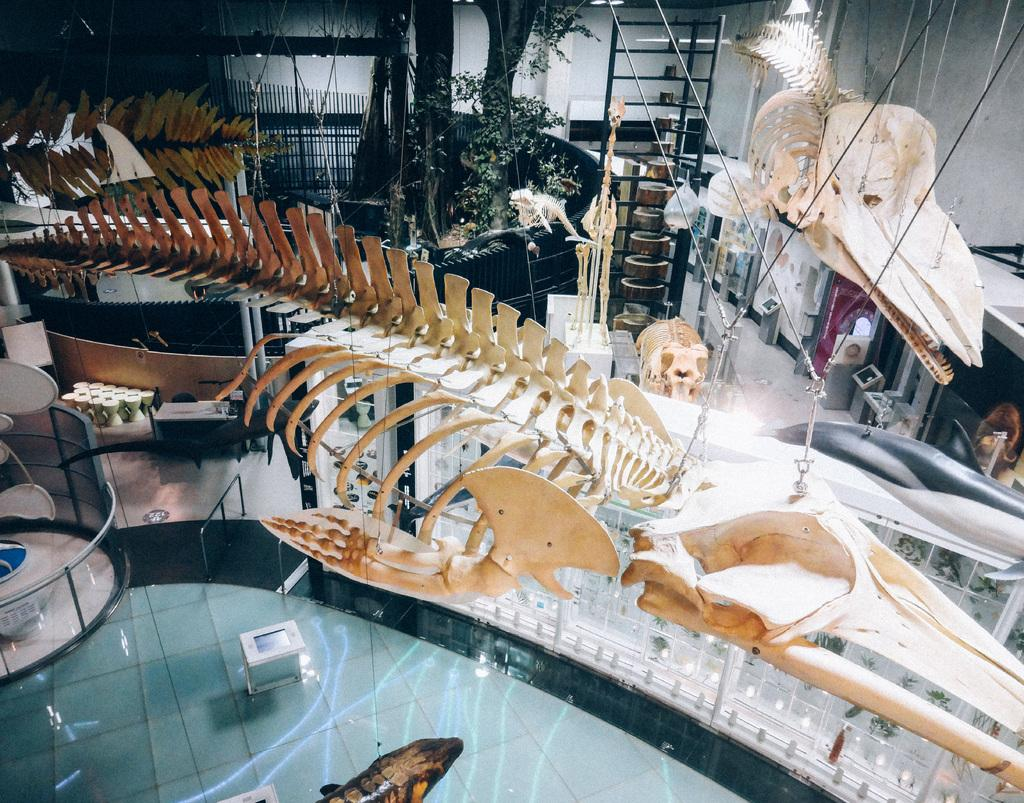What type of objects can be seen in the image? There are skeletons, glasses, a table, poles, ropes, a fence, trees, and a wall in the image. What might be used for holding liquids in the image? There are glasses in the image that might be used for holding liquids. What type of structure is present in the image? There is a table in the image, which is a type of structure. What type of barrier is present in the image? There is a fence in the image, which is a type of barrier. What type of vegetation is visible in the image? There are trees in the image, which is a type of vegetation. What type of surface is present in the image? There is a floor in the image, which is a type of surface. What type of peace can be seen in the image? There is no peace present in the image. --- Facts: 1. There is a car in the image. 12. The car is red. 13. There are people in the image. 14. The people are wearing hats. 15. There is a road in the image. 16. The road is paved. 17. There are streetlights in the image. 18. The streetlights are on. Absurd Topics: unicorn, rainbow, magic Conversation: What type of vehicle is present in the image? There is a car in the image. What color is the car in the image? The car is red in the image. What type of clothing are the people wearing in the image? The people are wearing hats in the image. What type of surface is present in the image? There is a road in the image, and it is paved. What type of lighting is present in the image? There are streetlights in the image, and they are on. Reasoning: Let's think step by step in order to produce the conversation. We start by identifying the main subject in the image, which is the red car. Next, we describe specific features of the car, such as its color. Then, we observe the actions of the people in the image, noting that they are wearing hats. Finally, we describe the natural setting visible in the image, which includes a paved road and streetlights that are on. Absurd Question/Answer: Can you see a unicorn in the image? There is no unicorn present in the image. 